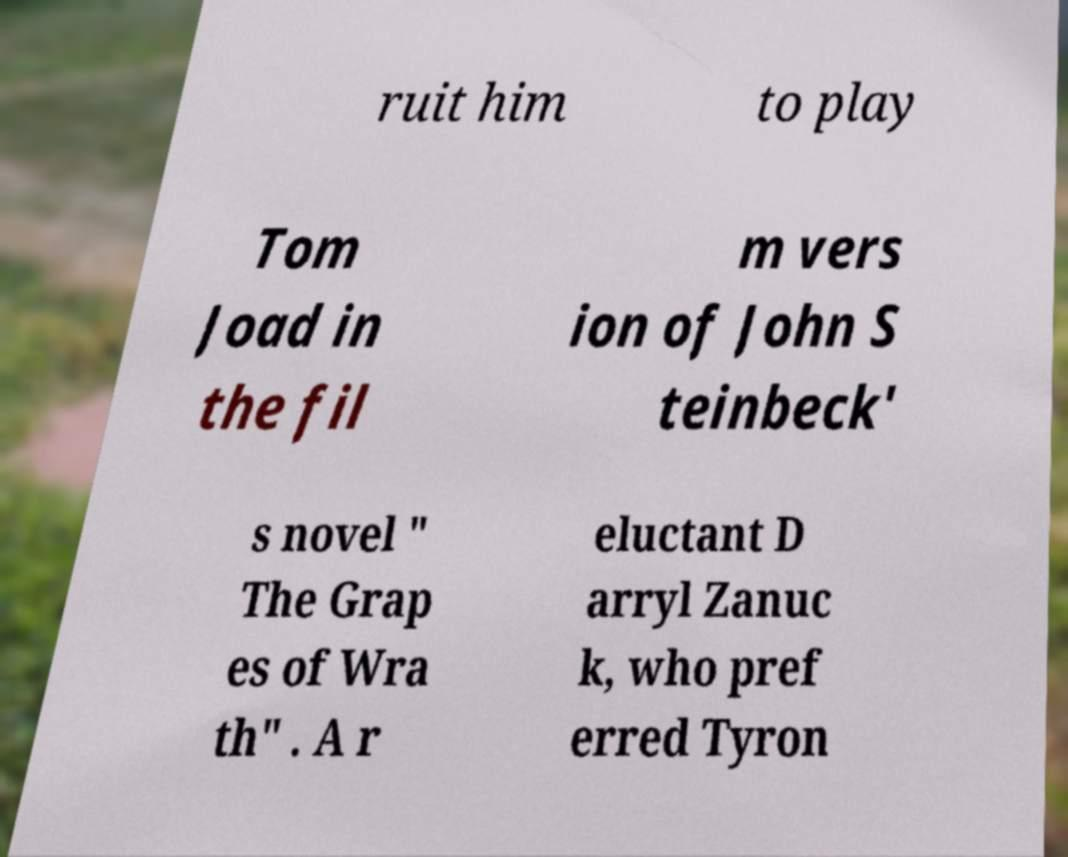What messages or text are displayed in this image? I need them in a readable, typed format. ruit him to play Tom Joad in the fil m vers ion of John S teinbeck' s novel " The Grap es of Wra th" . A r eluctant D arryl Zanuc k, who pref erred Tyron 